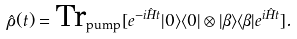<formula> <loc_0><loc_0><loc_500><loc_500>\hat { \rho } ( t ) = \text {Tr} _ { \text {pump} } [ e ^ { - i \hat { H } t } | 0 \rangle \langle 0 | \otimes | \beta \rangle \langle \beta | e ^ { i \hat { H } t } ] .</formula> 